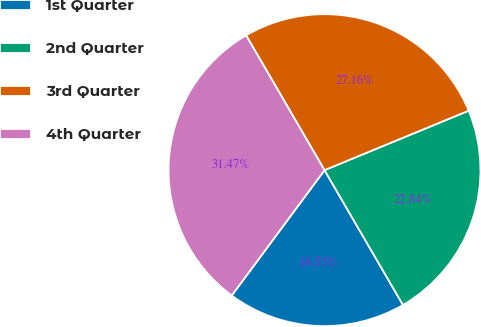Convert chart to OTSL. <chart><loc_0><loc_0><loc_500><loc_500><pie_chart><fcel>1st Quarter<fcel>2nd Quarter<fcel>3rd Quarter<fcel>4th Quarter<nl><fcel>18.53%<fcel>22.84%<fcel>27.16%<fcel>31.47%<nl></chart> 